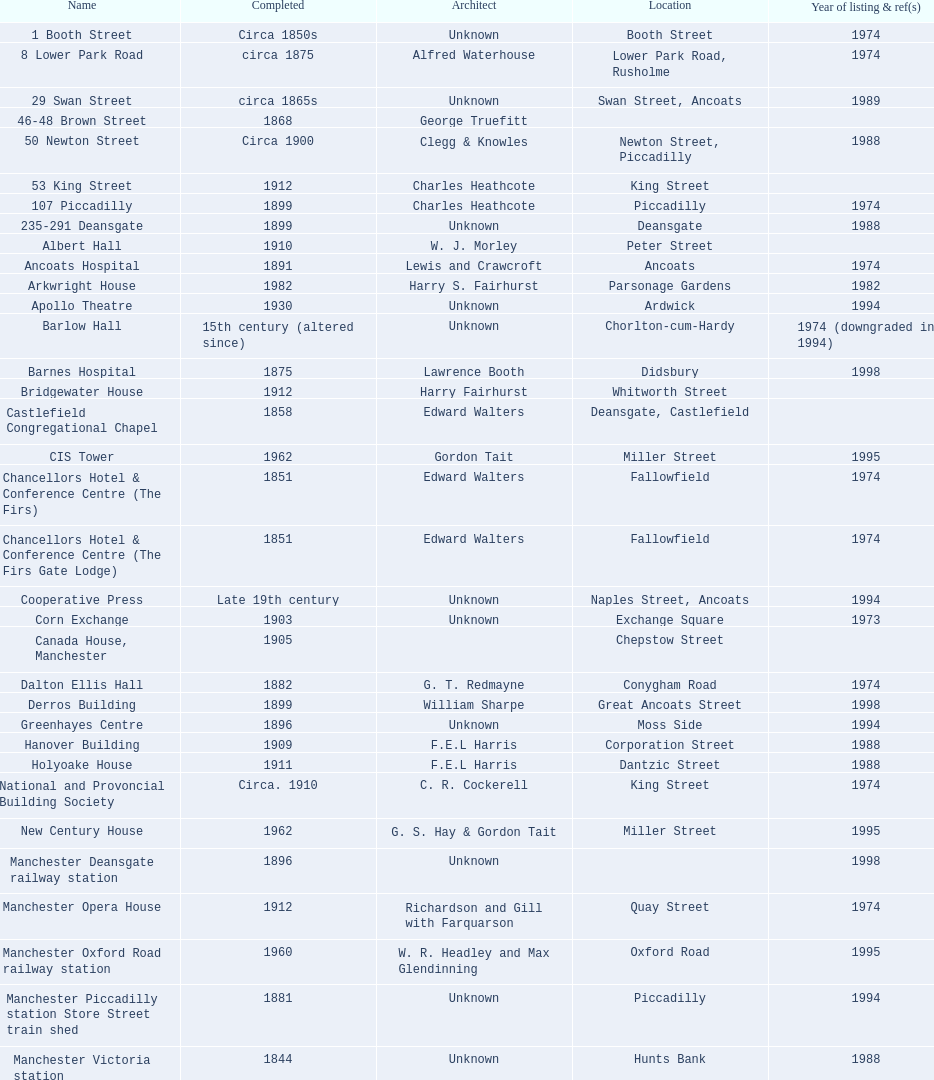How many years apart were the completion dates of 53 king street and castlefield congregational chapel? 54 years. 